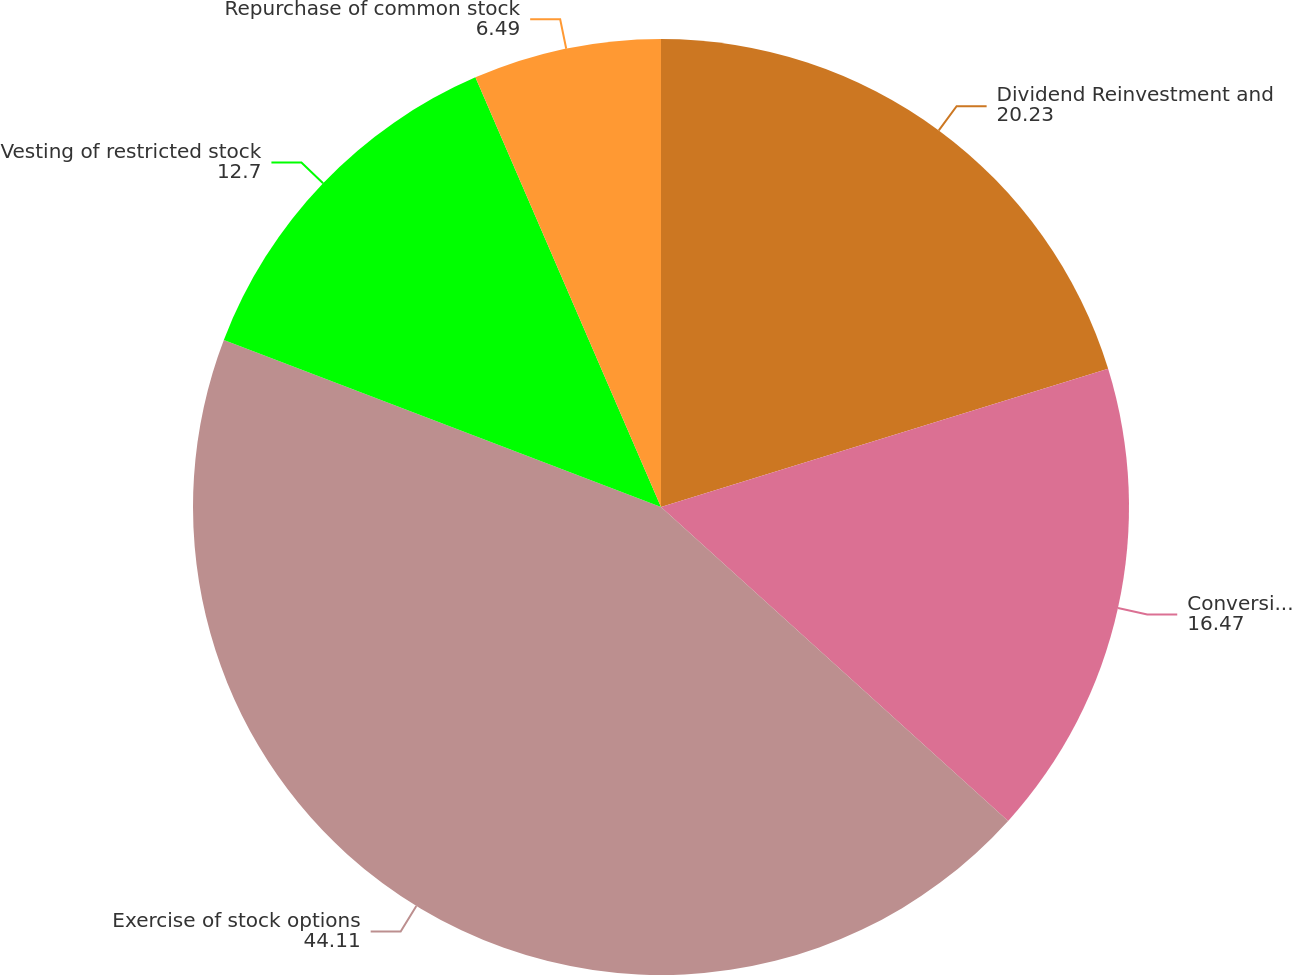Convert chart to OTSL. <chart><loc_0><loc_0><loc_500><loc_500><pie_chart><fcel>Dividend Reinvestment and<fcel>Conversion of DownREIT units<fcel>Exercise of stock options<fcel>Vesting of restricted stock<fcel>Repurchase of common stock<nl><fcel>20.23%<fcel>16.47%<fcel>44.11%<fcel>12.7%<fcel>6.49%<nl></chart> 